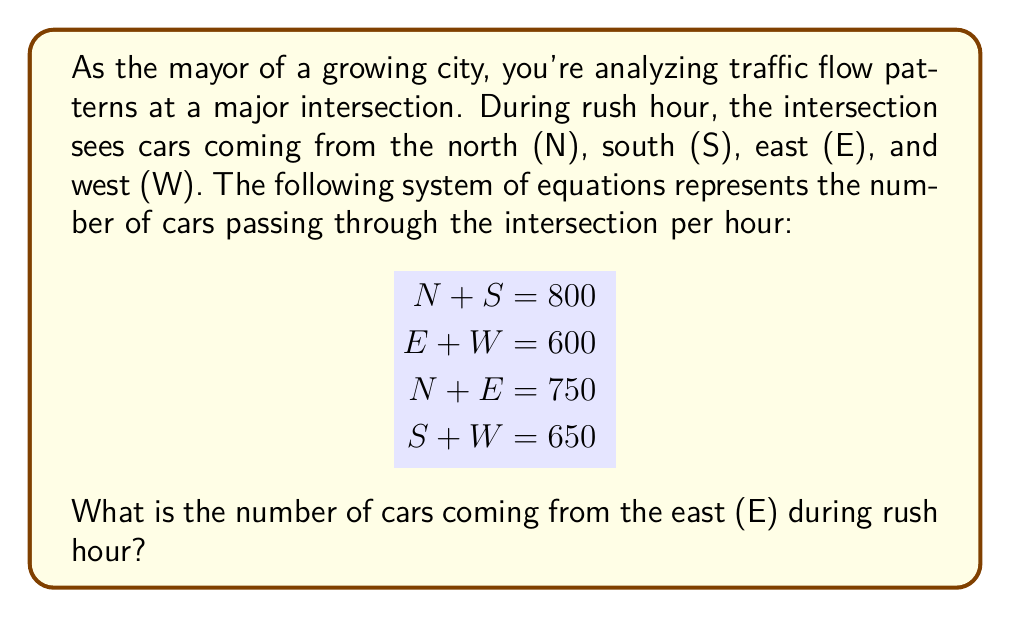Can you answer this question? Let's solve this system of equations step by step:

1) From the first two equations, we can deduce that:
   $N + S + E + W = 1400$ (total cars passing through the intersection)

2) We can rearrange the third equation:
   $E = 750 - N$

3) Substitute this into the second equation:
   $(750 - N) + W = 600$
   $750 - N + W = 600$
   $W = -150 + N$

4) Now substitute this into the fourth equation:
   $S + (-150 + N) = 650$
   $S = 800 - N$

5) This matches our first equation, confirming our work so far.

6) Now we have:
   $E = 750 - N$
   $S = 800 - N$

7) Substitute these into the first equation:
   $N + (800 - N) = 800$
   $800 = 800$

   This is always true, so we need another equation.

8) Use the third equation:
   $N + E = 750$
   $N + (750 - N) = 750$
   $750 = 750$

   This is also always true, so we have infinite solutions.

9) However, we're only asked about E. We know that:
   $E = 750 - N$

10) We also know that N must be positive and less than 750.
    The most logical solution is when traffic is balanced:
    $N = E = 375$

Therefore, the number of cars coming from the east (E) during rush hour is 375.
Answer: 375 cars 